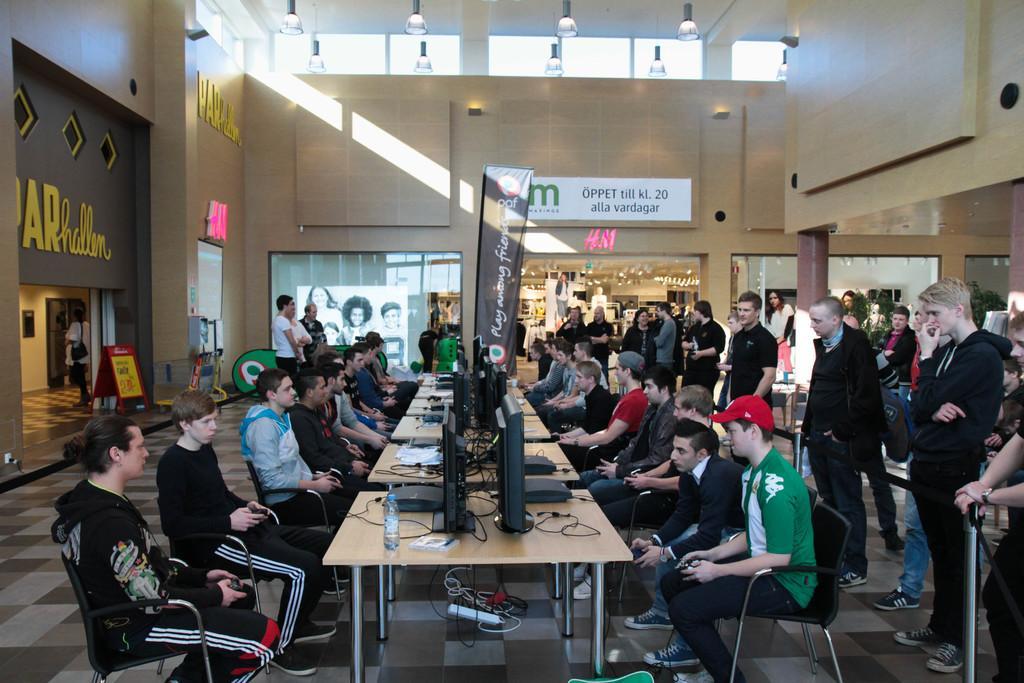Please provide a concise description of this image. Here we can see some persons are sitting on the chairs. These are the tables. On the table there are monitors, and bottles. This is floor. Here we can see some persons are standing on the floor. On the background there is a wall and this is banner. There is a board and this is glass. And there are lights. 